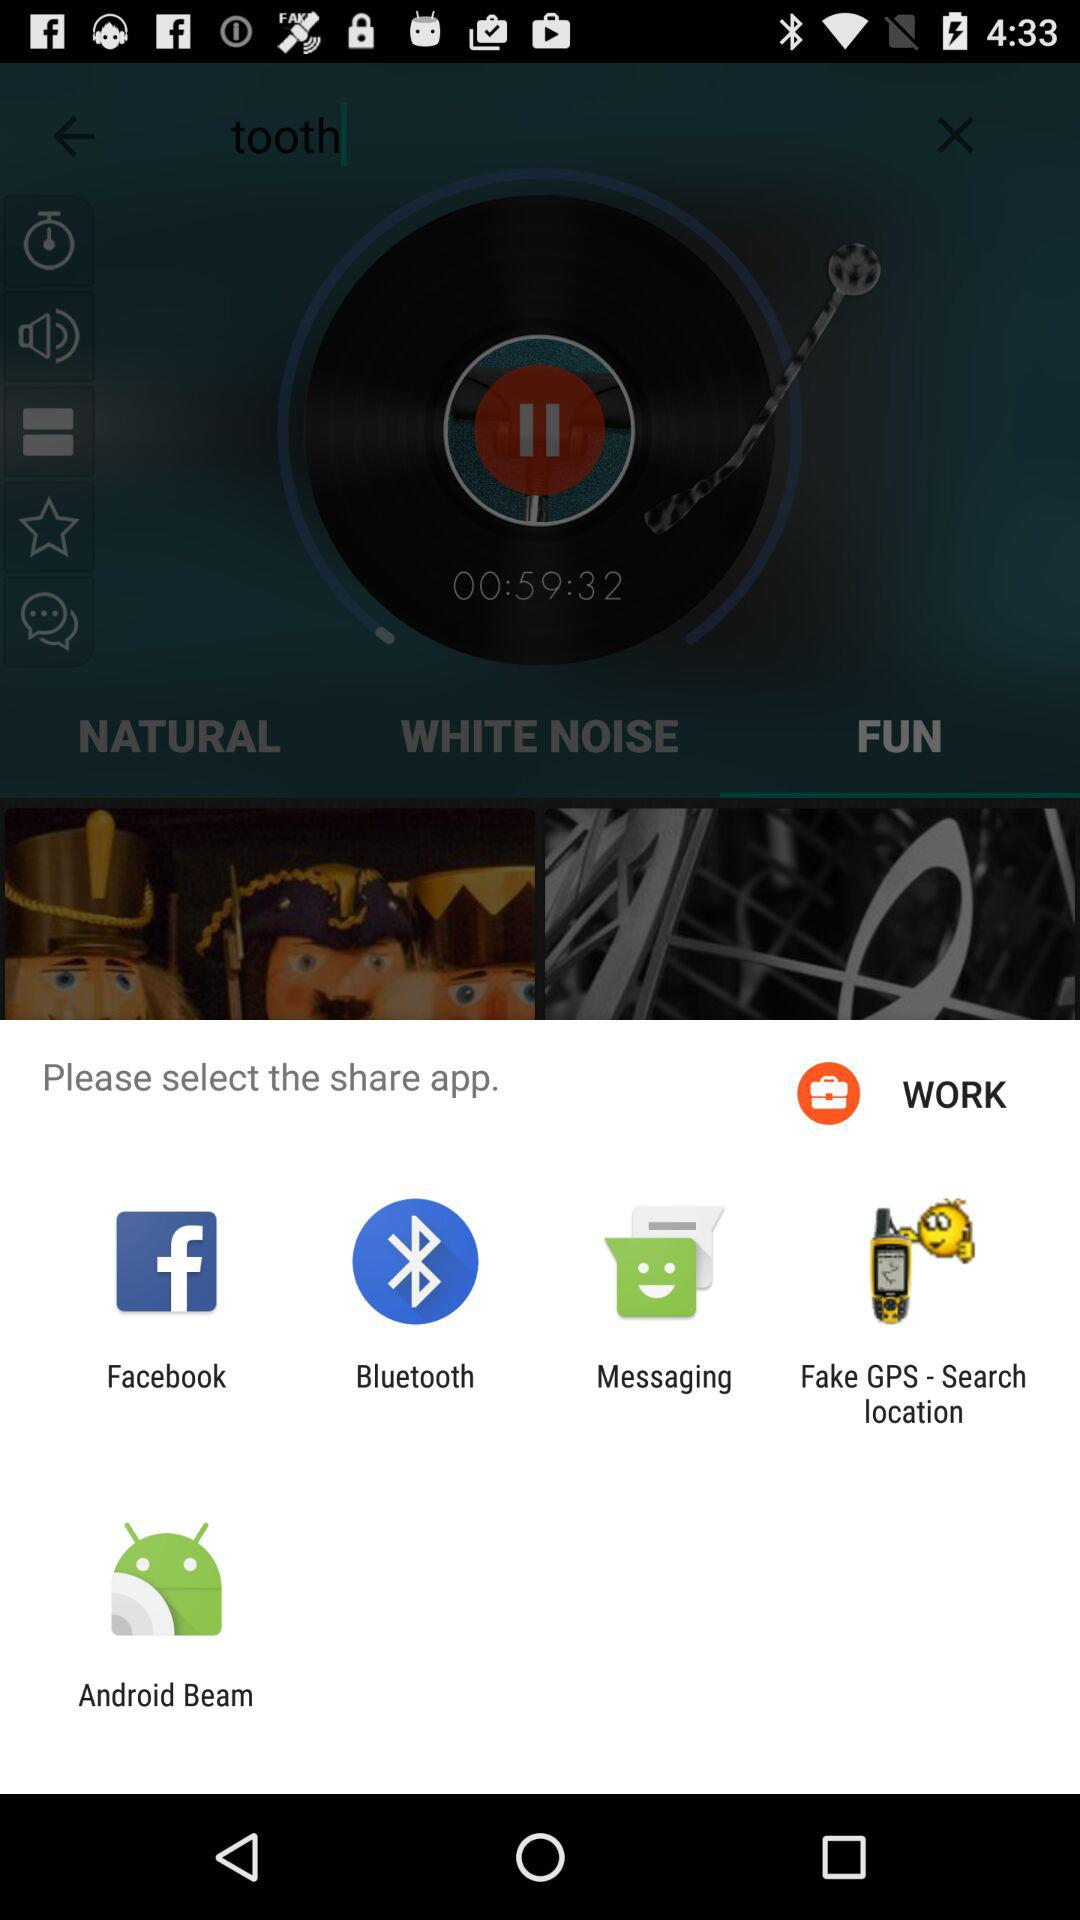What is the volume percentage of the audio?
When the provided information is insufficient, respond with <no answer>. <no answer> 